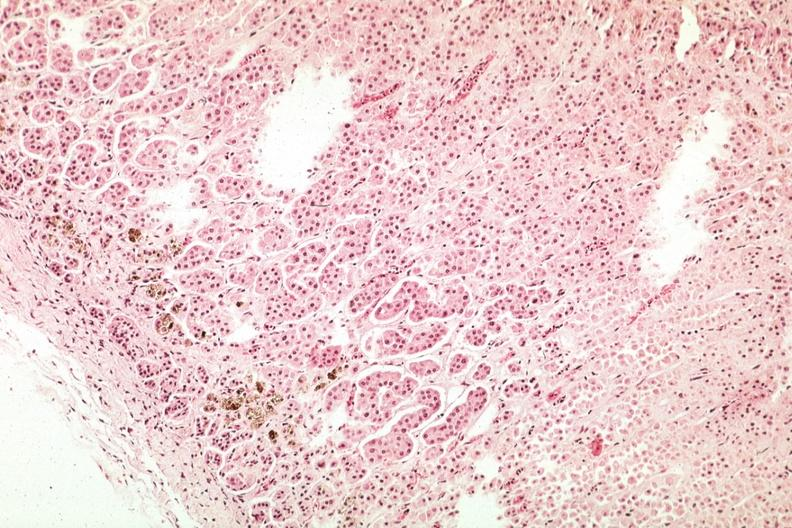s atherosclerosis present?
Answer the question using a single word or phrase. No 